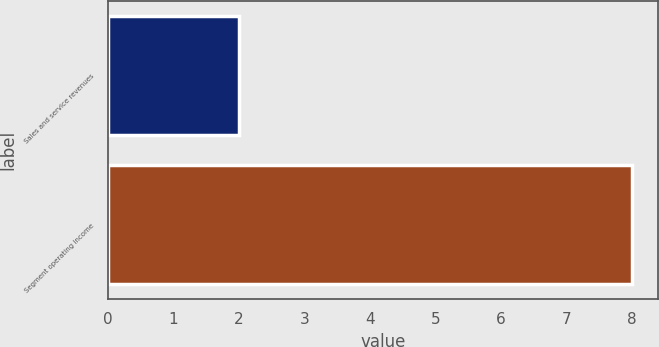Convert chart. <chart><loc_0><loc_0><loc_500><loc_500><bar_chart><fcel>Sales and service revenues<fcel>Segment operating income<nl><fcel>2<fcel>8<nl></chart> 